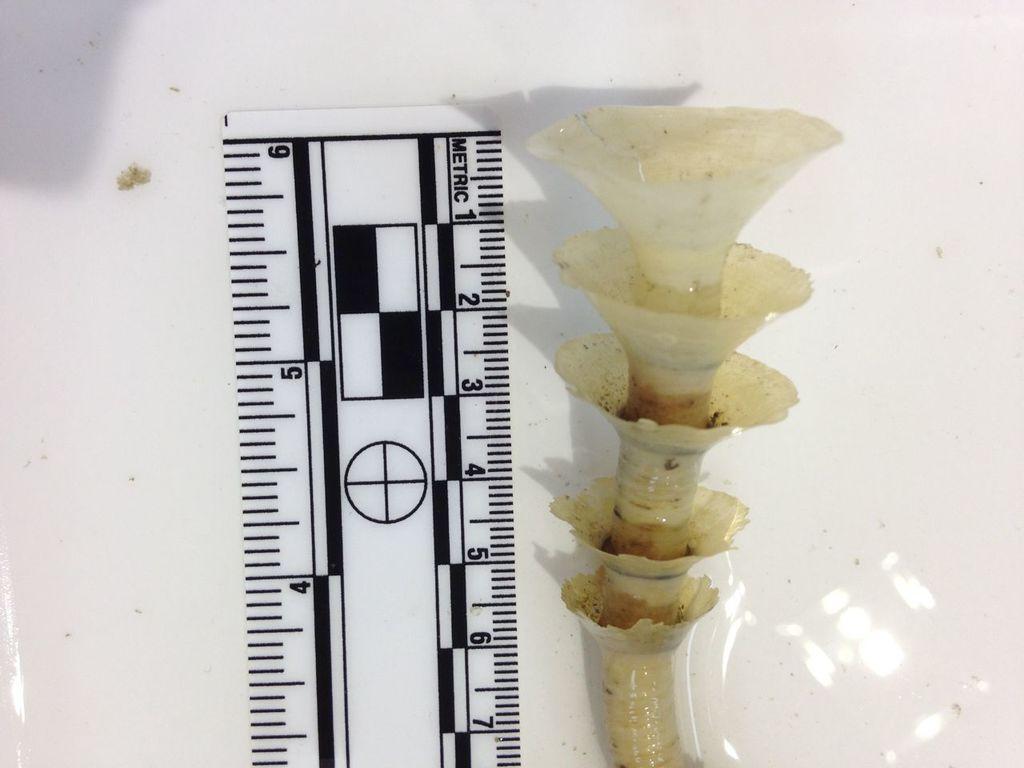What is the length in inches?
Keep it short and to the point. 6. 